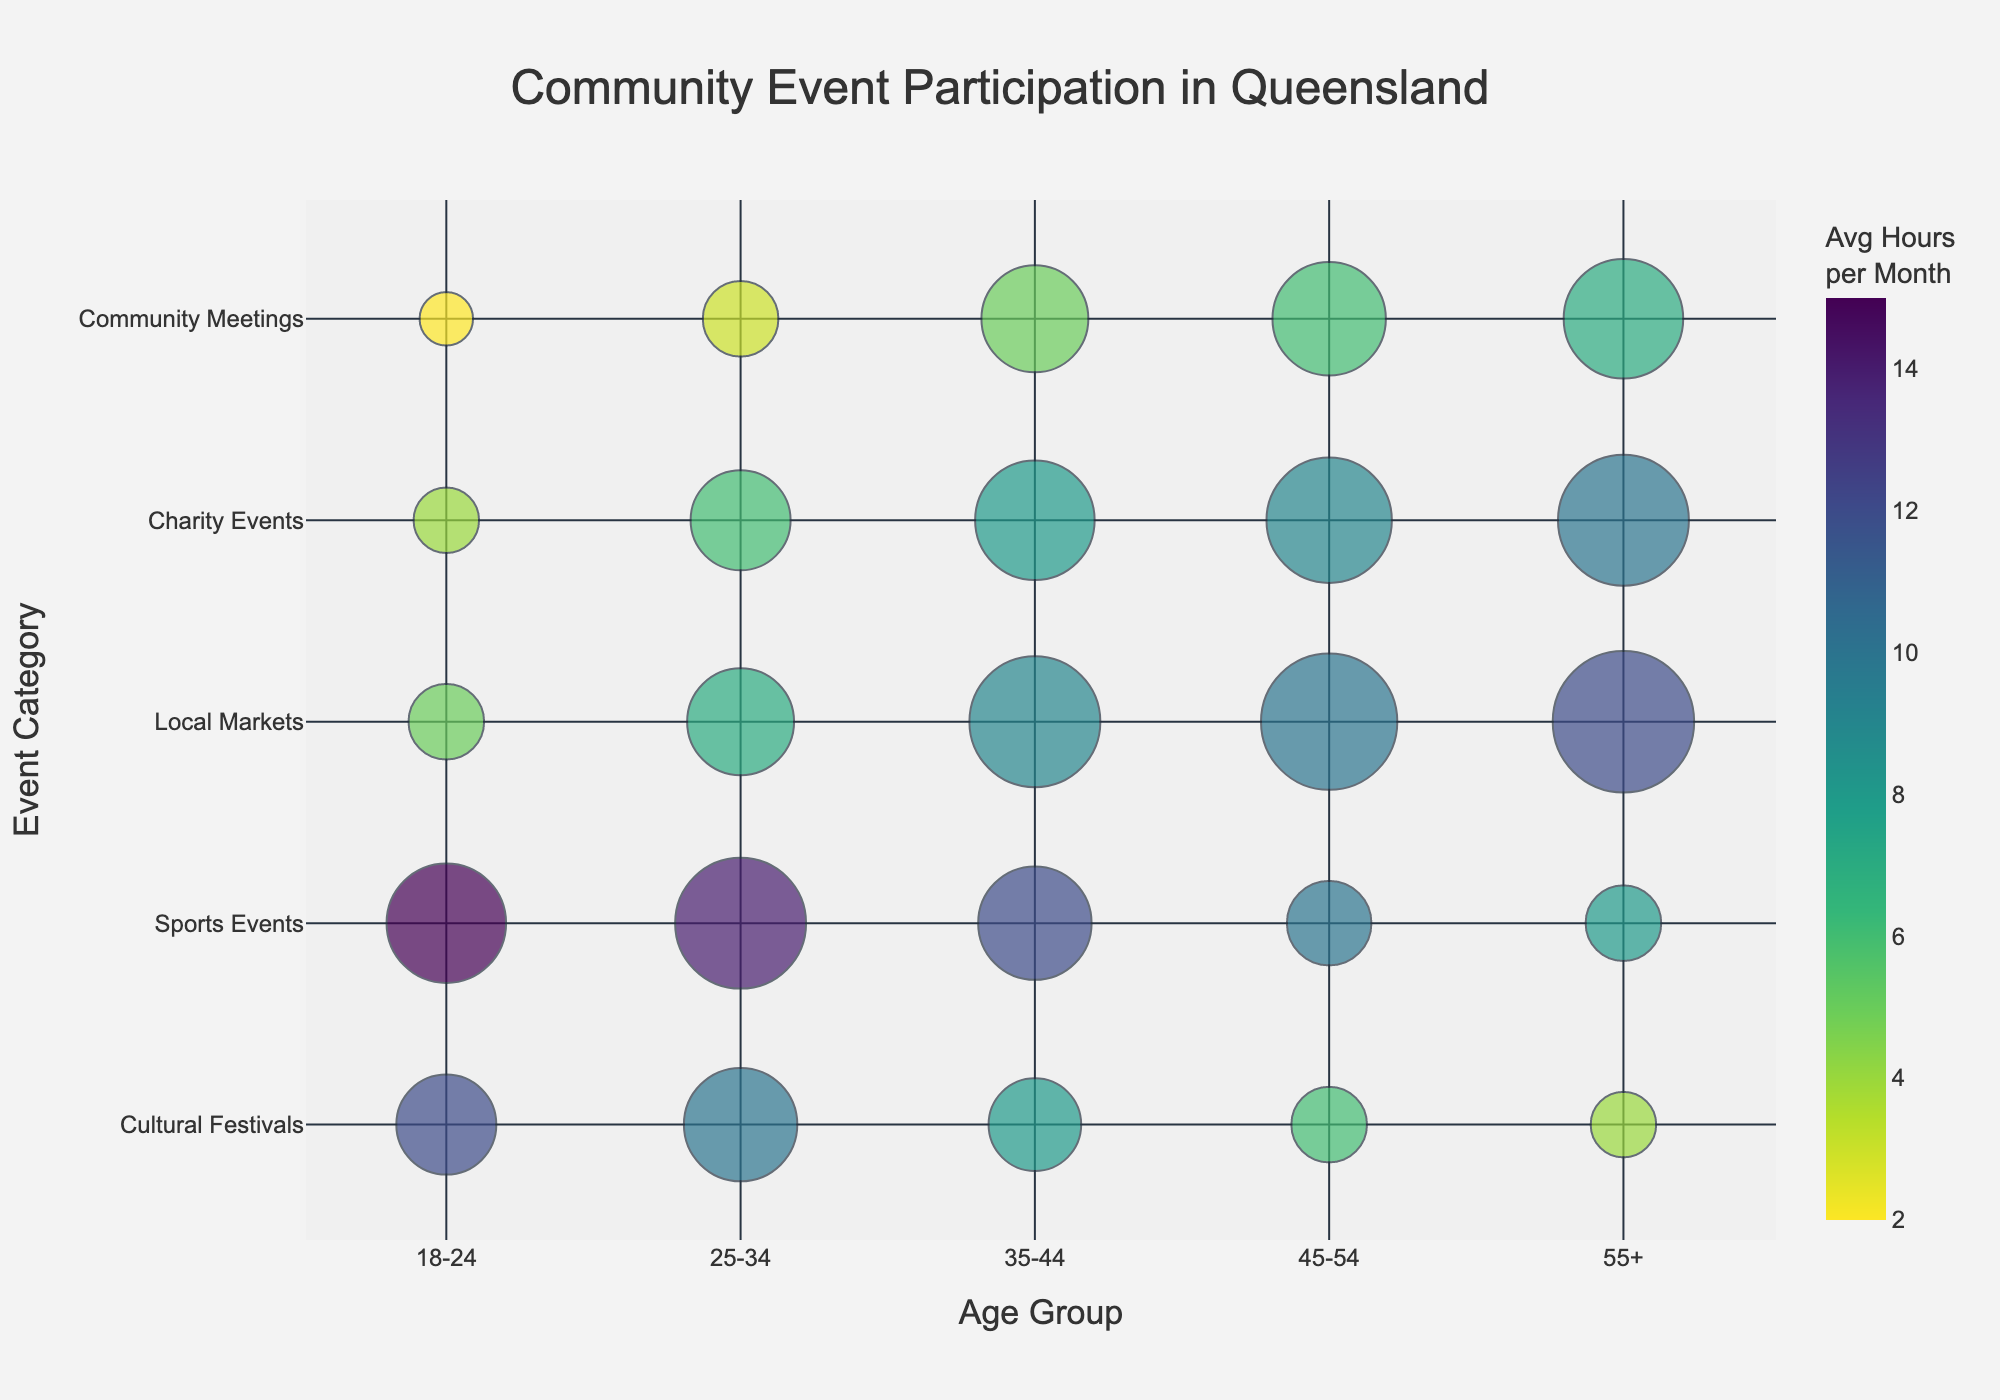How many event categories are shown in the chart? Count the unique event categories listed on the y-axis of the chart.
Answer: 5 Which age group has the largest bubble for Cultural Festivals? Look at the size of the bubbles in the row for Cultural Festivals. The largest bubble represents the age group with the most participants.
Answer: 25-34 What is the average number of hours per month for participants in Local Markets aged 55+? Check the color of the bubble for Local Markets in the 55+ age group and look for the corresponding value in the color bar.
Answer: 12 Compare the number of participants in Charity Events between the age groups 18-24 and 55+. Which age group has more participants? Look at the size of the bubbles for Charity Events in the 18-24 and 55+ rows. The larger bubble represents more participants.
Answer: 55+ For which event category do participants aged 45-54 spend the least average hours per month? Identify the bubble for age group 45-54 in each event category and look for the one with the lightest color, indicating the fewest hours per month.
Answer: Community Meetings What is the total number of participants for Sports Events across all age groups? Add the number of participants for each age group in the Sports Events category: 500 + 600 + 450 + 250 + 200.
Answer: 2000 Which event category has the most participants in the 35-44 age group? Look at the size of the bubbles for the 35-44 age group across all event categories. The largest bubble represents the category with the most participants.
Answer: Local Markets Does the age group 55+ participate more in Cultural Festivals or Community Meetings based on the number of participants? Compare the size of the bubbles in the 55+ row for Cultural Festivals and Community Meetings. The larger bubble indicates more participants.
Answer: Community Meetings For the 25-34 age group, which event category has participants spending the highest average hours per month? Look at the color of the bubbles in the 25-34 row and locate the darkest bubble, indicating the highest average hours.
Answer: Sports Events Which age group spends the least average hours per month in Community Meetings? Check the color of the bubbles in the Community Meetings row. The lightest bubble indicates the fewest hours per month.
Answer: 18-24 